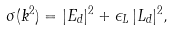Convert formula to latex. <formula><loc_0><loc_0><loc_500><loc_500>\sigma ( k ^ { 2 } ) = | E _ { d } | ^ { 2 } + \epsilon _ { L } \, | L _ { d } | ^ { 2 } ,</formula> 